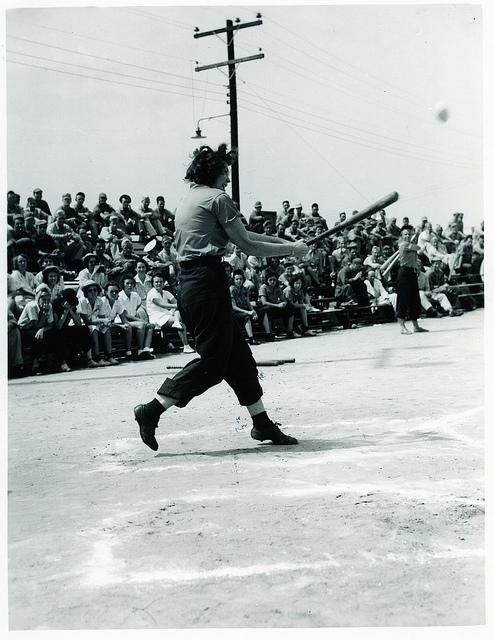What sport are these women most likely playing?

Choices:
A) tennis
B) softball
C) lacrosse
D) croquet softball 